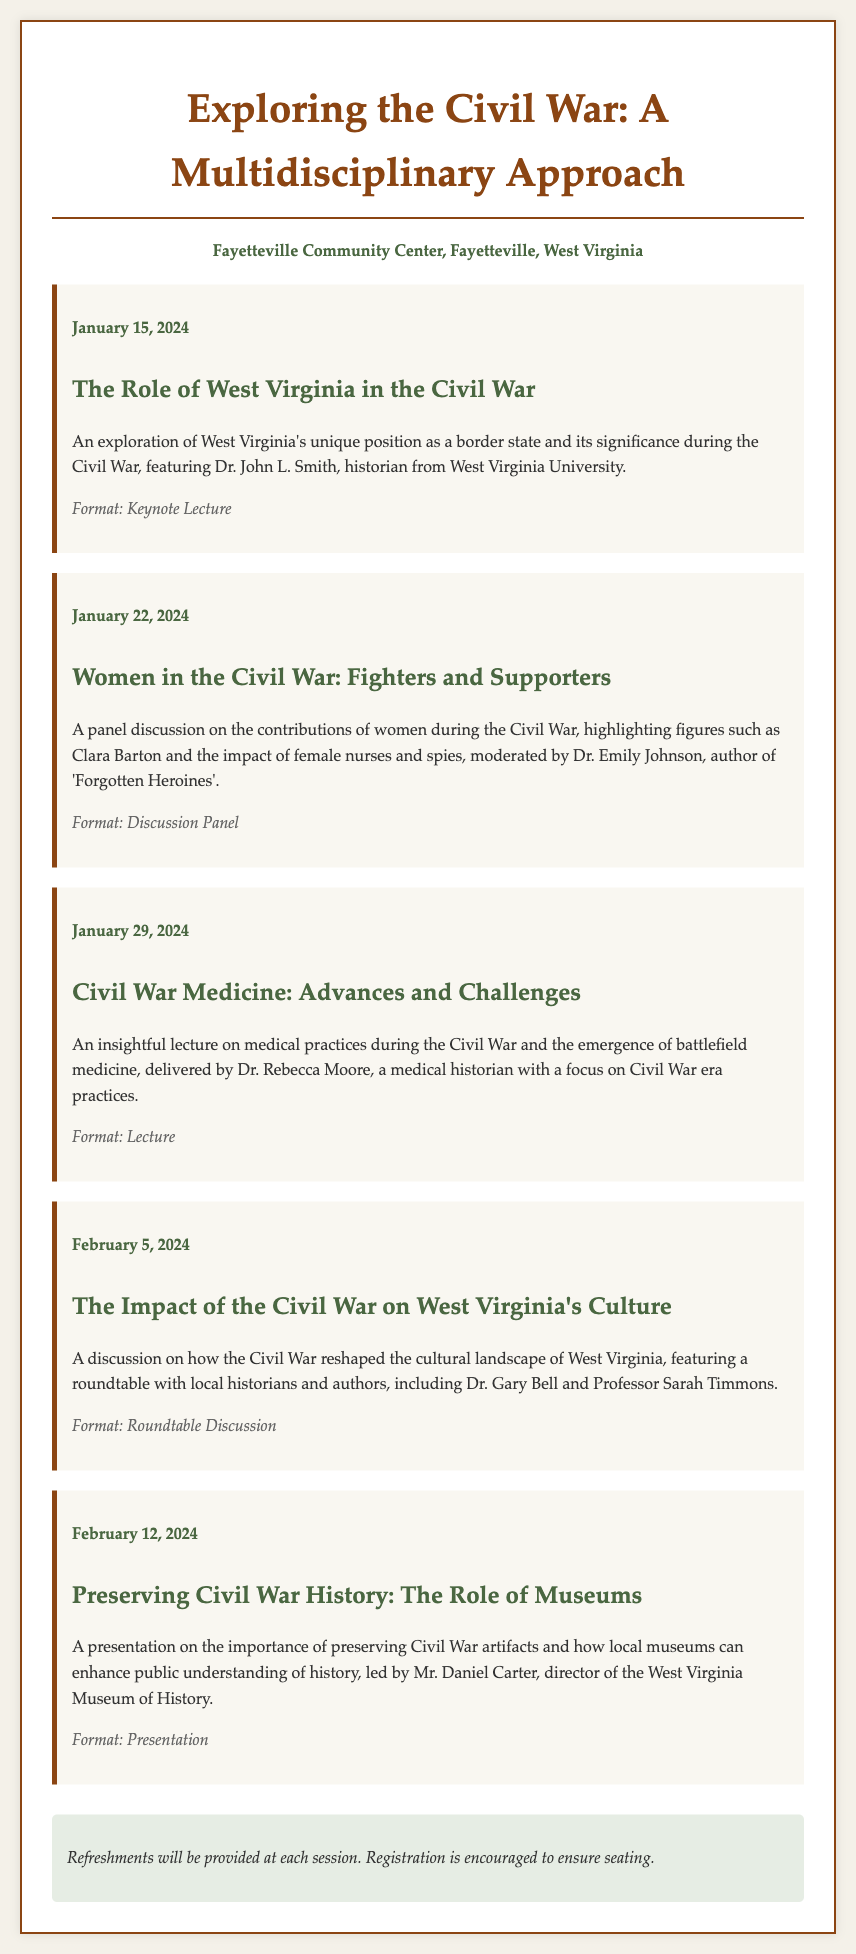What is the title of the lecture series? The title of the lecture series is stated at the beginning of the document.
Answer: Exploring the Civil War: A Multidisciplinary Approach When is the first lecture scheduled? The date of the first lecture is specifically mentioned in the document.
Answer: January 15, 2024 Who is the guest speaker for the lecture on "Women in the Civil War"? The document provides the name of the speaker for this specific panel discussion.
Answer: Dr. Emily Johnson What format will the session on "Preserving Civil War History: The Role of Museums" take? The format of each session is clearly indicated in the descriptions of the lectures.
Answer: Presentation How many lectures are scheduled for this series? The document lists all the lectures, allowing for a straightforward count.
Answer: Five What is the location of the lecture series? The location is stated prominently at the top of the document.
Answer: Fayetteville Community Center, Fayetteville, West Virginia Which topic discusses medical practices during the Civil War? The title of the relevant lecture is provided in the document.
Answer: Civil War Medicine: Advances and Challenges What will be provided at each session? The document includes a note about refreshments in all sessions.
Answer: Refreshments 